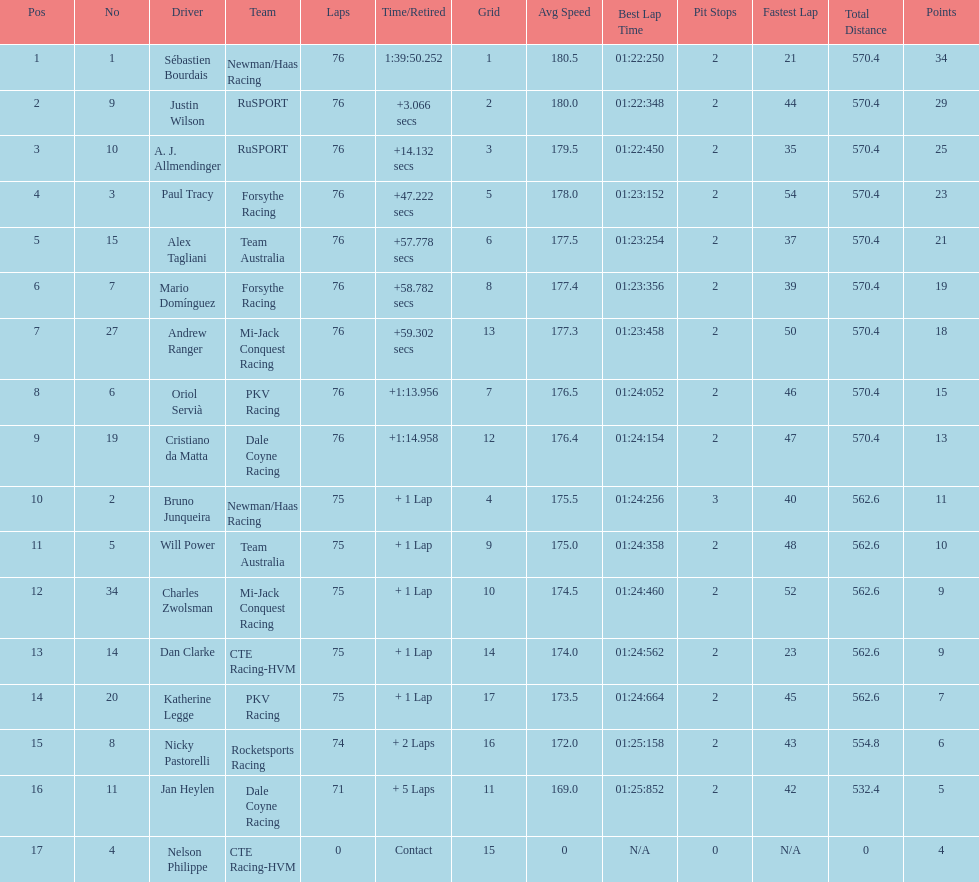Parse the table in full. {'header': ['Pos', 'No', 'Driver', 'Team', 'Laps', 'Time/Retired', 'Grid', 'Avg Speed', 'Best Lap Time', 'Pit Stops', 'Fastest Lap', 'Total Distance', 'Points'], 'rows': [['1', '1', 'Sébastien Bourdais', 'Newman/Haas Racing', '76', '1:39:50.252', '1', '180.5', '01:22:250', '2', '21', '570.4', '34'], ['2', '9', 'Justin Wilson', 'RuSPORT', '76', '+3.066 secs', '2', '180.0', '01:22:348', '2', '44', '570.4', '29'], ['3', '10', 'A. J. Allmendinger', 'RuSPORT', '76', '+14.132 secs', '3', '179.5', '01:22:450', '2', '35', '570.4', '25'], ['4', '3', 'Paul Tracy', 'Forsythe Racing', '76', '+47.222 secs', '5', '178.0', '01:23:152', '2', '54', '570.4', '23'], ['5', '15', 'Alex Tagliani', 'Team Australia', '76', '+57.778 secs', '6', '177.5', '01:23:254', '2', '37', '570.4', '21'], ['6', '7', 'Mario Domínguez', 'Forsythe Racing', '76', '+58.782 secs', '8', '177.4', '01:23:356', '2', '39', '570.4', '19'], ['7', '27', 'Andrew Ranger', 'Mi-Jack Conquest Racing', '76', '+59.302 secs', '13', '177.3', '01:23:458', '2', '50', '570.4', '18'], ['8', '6', 'Oriol Servià', 'PKV Racing', '76', '+1:13.956', '7', '176.5', '01:24:052', '2', '46', '570.4', '15'], ['9', '19', 'Cristiano da Matta', 'Dale Coyne Racing', '76', '+1:14.958', '12', '176.4', '01:24:154', '2', '47', '570.4', '13'], ['10', '2', 'Bruno Junqueira', 'Newman/Haas Racing', '75', '+ 1 Lap', '4', '175.5', '01:24:256', '3', '40', '562.6', '11'], ['11', '5', 'Will Power', 'Team Australia', '75', '+ 1 Lap', '9', '175.0', '01:24:358', '2', '48', '562.6', '10'], ['12', '34', 'Charles Zwolsman', 'Mi-Jack Conquest Racing', '75', '+ 1 Lap', '10', '174.5', '01:24:460', '2', '52', '562.6', '9'], ['13', '14', 'Dan Clarke', 'CTE Racing-HVM', '75', '+ 1 Lap', '14', '174.0', '01:24:562', '2', '23', '562.6', '9'], ['14', '20', 'Katherine Legge', 'PKV Racing', '75', '+ 1 Lap', '17', '173.5', '01:24:664', '2', '45', '562.6', '7'], ['15', '8', 'Nicky Pastorelli', 'Rocketsports Racing', '74', '+ 2 Laps', '16', '172.0', '01:25:158', '2', '43', '554.8', '6'], ['16', '11', 'Jan Heylen', 'Dale Coyne Racing', '71', '+ 5 Laps', '11', '169.0', '01:25:852', '2', '42', '532.4', '5'], ['17', '4', 'Nelson Philippe', 'CTE Racing-HVM', '0', 'Contact', '15', '0', 'N/A', '0', 'N/A', '0', '4']]} Which canadian driver finished first: alex tagliani or paul tracy? Paul Tracy. 